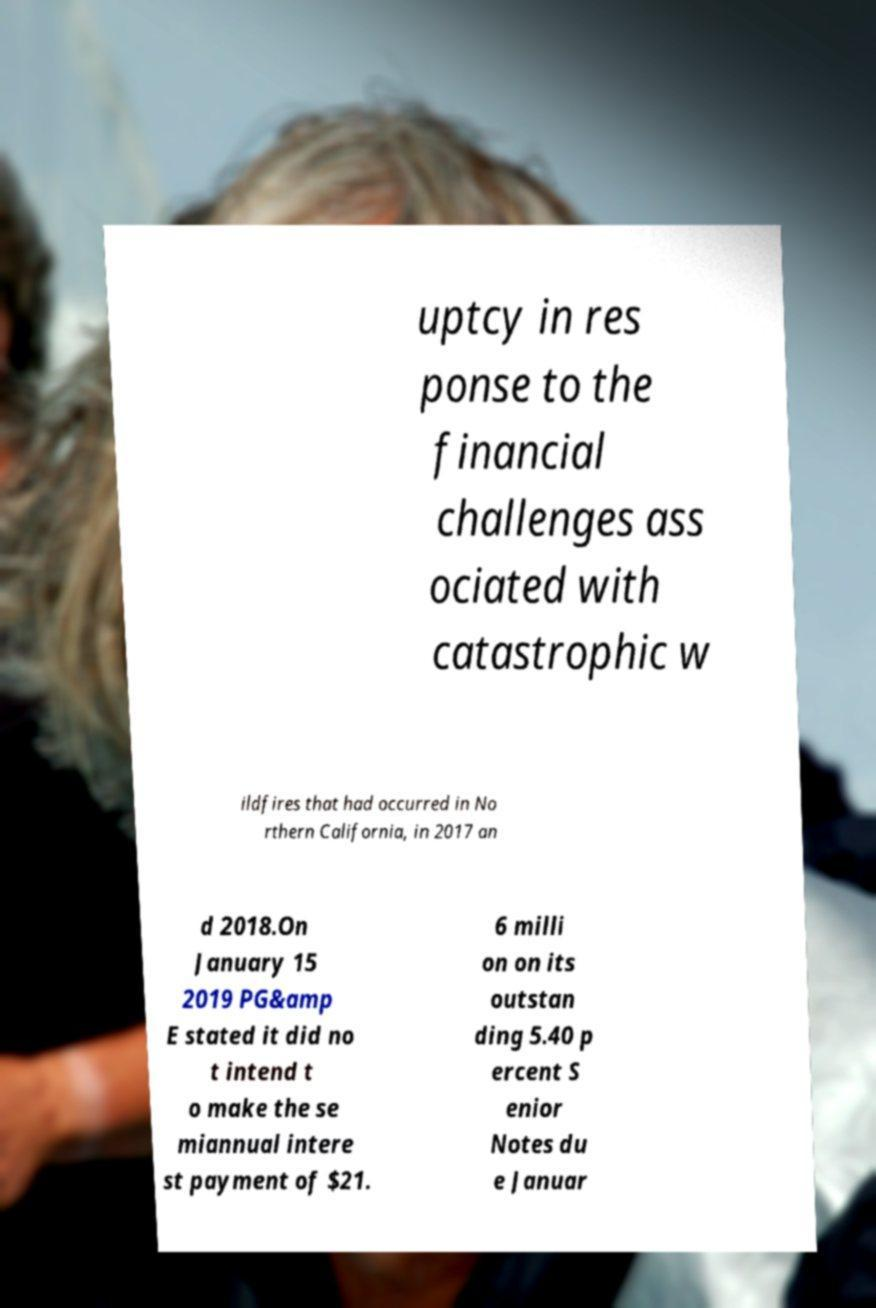Please read and relay the text visible in this image. What does it say? uptcy in res ponse to the financial challenges ass ociated with catastrophic w ildfires that had occurred in No rthern California, in 2017 an d 2018.On January 15 2019 PG&amp E stated it did no t intend t o make the se miannual intere st payment of $21. 6 milli on on its outstan ding 5.40 p ercent S enior Notes du e Januar 